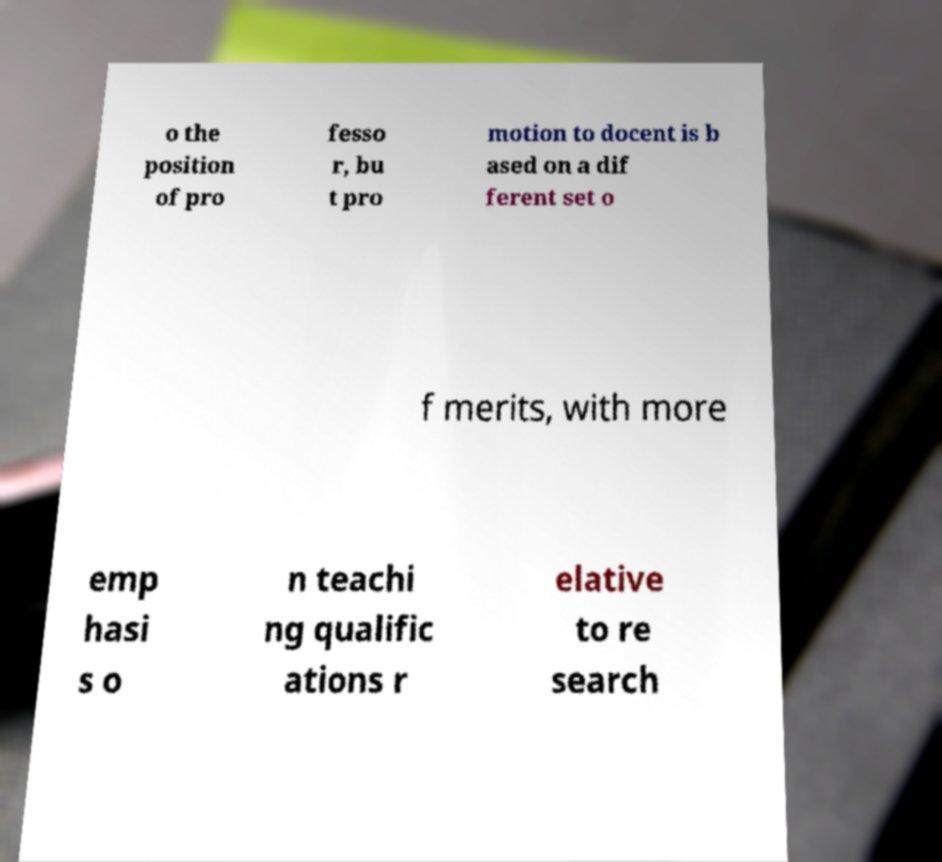Please identify and transcribe the text found in this image. o the position of pro fesso r, bu t pro motion to docent is b ased on a dif ferent set o f merits, with more emp hasi s o n teachi ng qualific ations r elative to re search 